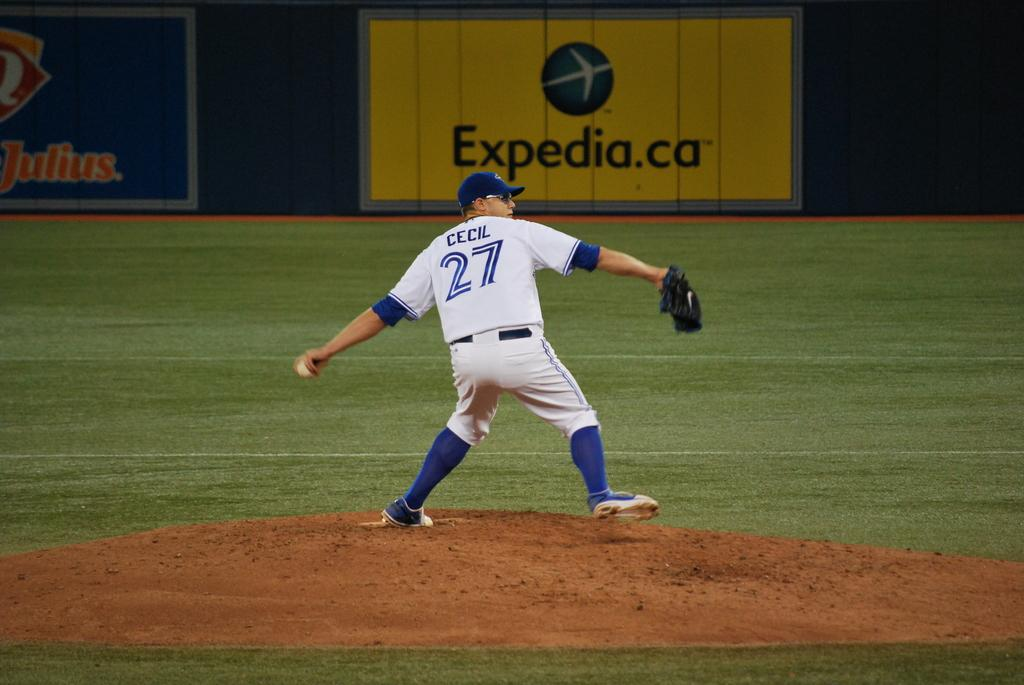<image>
Share a concise interpretation of the image provided. Baseball player named Cecil and number 27 getting ready to throw the ball. 